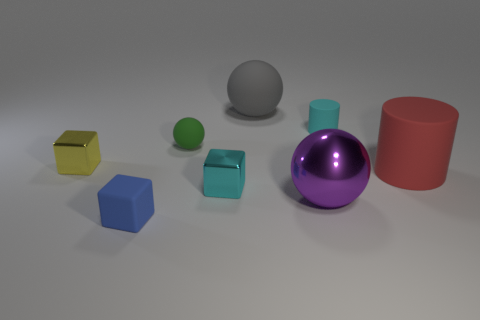Add 1 small cyan blocks. How many objects exist? 9 Subtract all spheres. How many objects are left? 5 Add 2 metallic balls. How many metallic balls are left? 3 Add 1 brown matte cubes. How many brown matte cubes exist? 1 Subtract 0 yellow cylinders. How many objects are left? 8 Subtract all cyan objects. Subtract all small blue rubber objects. How many objects are left? 5 